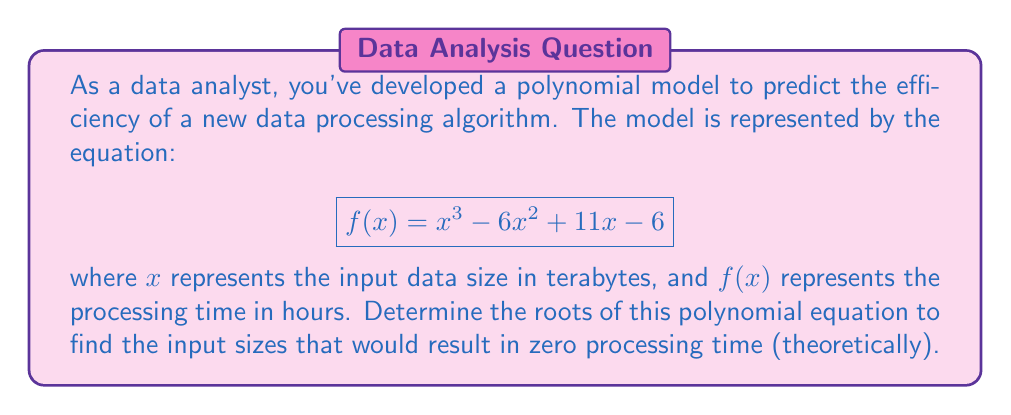Could you help me with this problem? To find the roots of the polynomial equation, we need to solve:

$$x^3 - 6x^2 + 11x - 6 = 0$$

Let's approach this step-by-step:

1) First, we can try to factor out any common factors. In this case, there are none.

2) Next, we can check if there's an obvious root. Let's try $x = 1$:
   
   $1^3 - 6(1)^2 + 11(1) - 6 = 1 - 6 + 11 - 6 = 0$

   So, $x = 1$ is a root.

3) Now we can factor out $(x - 1)$:
   
   $x^3 - 6x^2 + 11x - 6 = (x - 1)(x^2 - 5x + 6)$

4) We're left with a quadratic equation to solve: $x^2 - 5x + 6 = 0$

5) We can solve this using the quadratic formula: $x = \frac{-b \pm \sqrt{b^2 - 4ac}}{2a}$

   Where $a = 1$, $b = -5$, and $c = 6$

6) Plugging in these values:
   
   $x = \frac{5 \pm \sqrt{25 - 24}}{2} = \frac{5 \pm 1}{2}$

7) This gives us the other two roots:
   
   $x = \frac{5 + 1}{2} = 3$ and $x = \frac{5 - 1}{2} = 2$

Therefore, the roots of the polynomial are 1, 2, and 3.
Answer: $x = 1$, $x = 2$, and $x = 3$ 